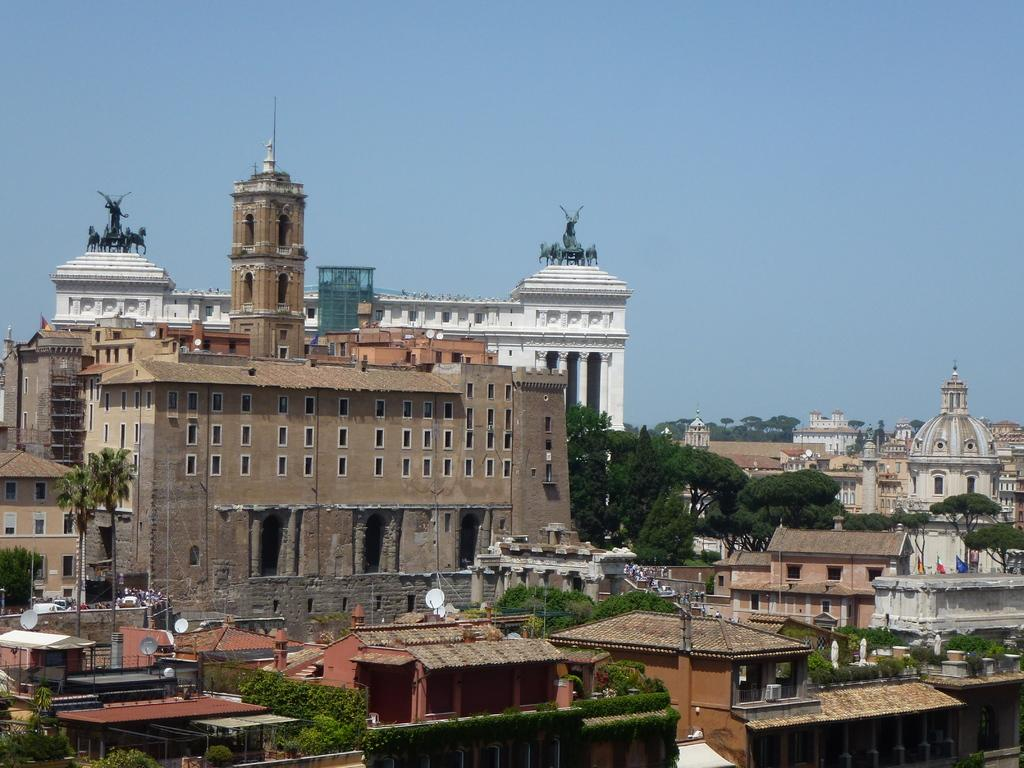What type of structures are present in the image? There are buildings in the image. What other natural elements can be seen in the image? There are trees in the image. What is visible at the top of the image? The sky is visible at the top of the image. What types of toys can be seen on the ground in the image? There are no toys present in the image; it features buildings, trees, and the sky. Can you tell me the color of the uncle's shirt in the image? There is no uncle present in the image, so it is not possible to determine the color of his shirt. 